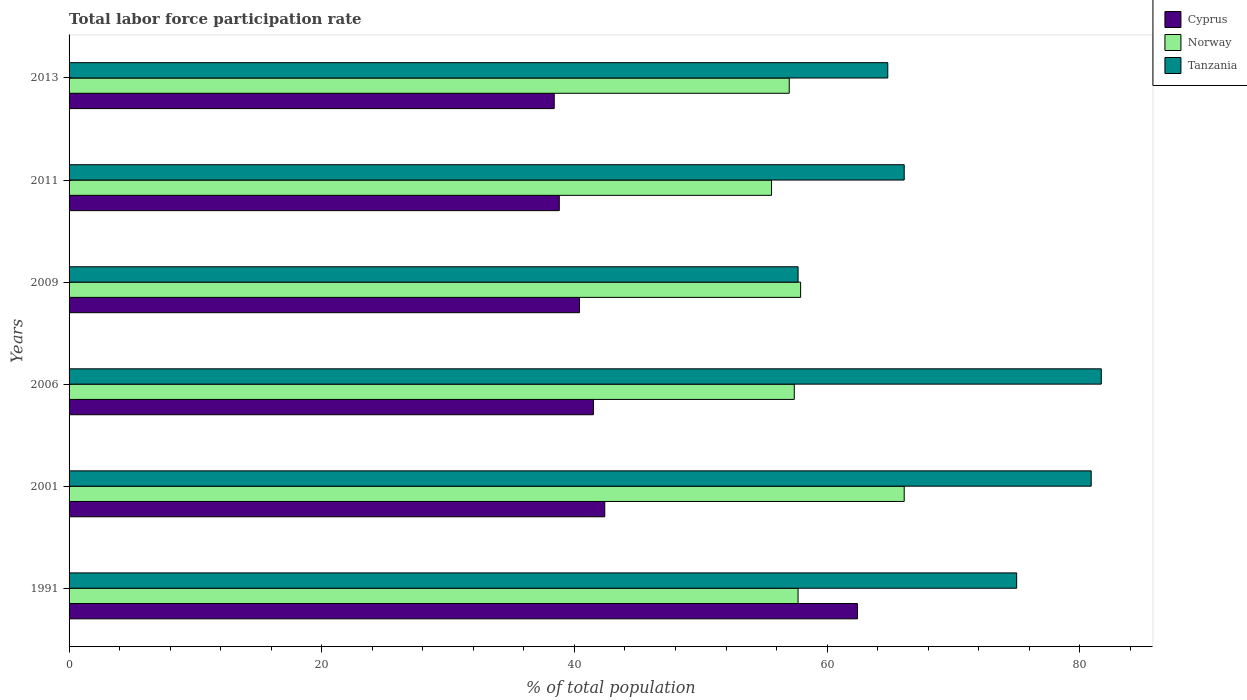How many different coloured bars are there?
Offer a terse response. 3. Are the number of bars per tick equal to the number of legend labels?
Your answer should be very brief. Yes. How many bars are there on the 4th tick from the top?
Give a very brief answer. 3. How many bars are there on the 6th tick from the bottom?
Your answer should be very brief. 3. What is the label of the 4th group of bars from the top?
Your answer should be compact. 2006. In how many cases, is the number of bars for a given year not equal to the number of legend labels?
Your answer should be very brief. 0. What is the total labor force participation rate in Norway in 2009?
Keep it short and to the point. 57.9. Across all years, what is the maximum total labor force participation rate in Norway?
Provide a succinct answer. 66.1. Across all years, what is the minimum total labor force participation rate in Cyprus?
Provide a short and direct response. 38.4. In which year was the total labor force participation rate in Norway minimum?
Your answer should be very brief. 2011. What is the total total labor force participation rate in Norway in the graph?
Offer a terse response. 351.7. What is the difference between the total labor force participation rate in Tanzania in 2001 and that in 2011?
Offer a terse response. 14.8. What is the difference between the total labor force participation rate in Cyprus in 2009 and the total labor force participation rate in Norway in 1991?
Give a very brief answer. -17.3. What is the average total labor force participation rate in Cyprus per year?
Give a very brief answer. 43.98. In the year 2006, what is the difference between the total labor force participation rate in Norway and total labor force participation rate in Tanzania?
Offer a very short reply. -24.3. In how many years, is the total labor force participation rate in Norway greater than 52 %?
Your answer should be compact. 6. What is the ratio of the total labor force participation rate in Norway in 2001 to that in 2013?
Make the answer very short. 1.16. What is the difference between the highest and the second highest total labor force participation rate in Norway?
Make the answer very short. 8.2. What is the difference between the highest and the lowest total labor force participation rate in Cyprus?
Provide a succinct answer. 24. In how many years, is the total labor force participation rate in Tanzania greater than the average total labor force participation rate in Tanzania taken over all years?
Your answer should be very brief. 3. Is the sum of the total labor force participation rate in Cyprus in 2011 and 2013 greater than the maximum total labor force participation rate in Tanzania across all years?
Offer a very short reply. No. What does the 1st bar from the top in 2011 represents?
Offer a very short reply. Tanzania. What does the 3rd bar from the bottom in 2013 represents?
Your response must be concise. Tanzania. How many bars are there?
Provide a succinct answer. 18. Are all the bars in the graph horizontal?
Provide a short and direct response. Yes. How many years are there in the graph?
Make the answer very short. 6. What is the difference between two consecutive major ticks on the X-axis?
Offer a very short reply. 20. How many legend labels are there?
Make the answer very short. 3. What is the title of the graph?
Keep it short and to the point. Total labor force participation rate. Does "Latin America(all income levels)" appear as one of the legend labels in the graph?
Your answer should be compact. No. What is the label or title of the X-axis?
Your response must be concise. % of total population. What is the label or title of the Y-axis?
Your response must be concise. Years. What is the % of total population of Cyprus in 1991?
Ensure brevity in your answer.  62.4. What is the % of total population of Norway in 1991?
Your answer should be very brief. 57.7. What is the % of total population of Tanzania in 1991?
Keep it short and to the point. 75. What is the % of total population of Cyprus in 2001?
Offer a terse response. 42.4. What is the % of total population in Norway in 2001?
Your answer should be compact. 66.1. What is the % of total population in Tanzania in 2001?
Offer a terse response. 80.9. What is the % of total population of Cyprus in 2006?
Keep it short and to the point. 41.5. What is the % of total population in Norway in 2006?
Provide a short and direct response. 57.4. What is the % of total population in Tanzania in 2006?
Your answer should be compact. 81.7. What is the % of total population of Cyprus in 2009?
Give a very brief answer. 40.4. What is the % of total population of Norway in 2009?
Your response must be concise. 57.9. What is the % of total population in Tanzania in 2009?
Your answer should be compact. 57.7. What is the % of total population of Cyprus in 2011?
Your answer should be compact. 38.8. What is the % of total population of Norway in 2011?
Keep it short and to the point. 55.6. What is the % of total population in Tanzania in 2011?
Your response must be concise. 66.1. What is the % of total population of Cyprus in 2013?
Offer a very short reply. 38.4. What is the % of total population of Tanzania in 2013?
Your response must be concise. 64.8. Across all years, what is the maximum % of total population in Cyprus?
Offer a terse response. 62.4. Across all years, what is the maximum % of total population in Norway?
Give a very brief answer. 66.1. Across all years, what is the maximum % of total population in Tanzania?
Offer a very short reply. 81.7. Across all years, what is the minimum % of total population in Cyprus?
Make the answer very short. 38.4. Across all years, what is the minimum % of total population in Norway?
Your answer should be very brief. 55.6. Across all years, what is the minimum % of total population of Tanzania?
Provide a succinct answer. 57.7. What is the total % of total population in Cyprus in the graph?
Make the answer very short. 263.9. What is the total % of total population in Norway in the graph?
Offer a terse response. 351.7. What is the total % of total population in Tanzania in the graph?
Your answer should be compact. 426.2. What is the difference between the % of total population in Cyprus in 1991 and that in 2001?
Your response must be concise. 20. What is the difference between the % of total population in Cyprus in 1991 and that in 2006?
Make the answer very short. 20.9. What is the difference between the % of total population of Cyprus in 1991 and that in 2009?
Provide a short and direct response. 22. What is the difference between the % of total population in Tanzania in 1991 and that in 2009?
Your response must be concise. 17.3. What is the difference between the % of total population in Cyprus in 1991 and that in 2011?
Offer a terse response. 23.6. What is the difference between the % of total population of Cyprus in 1991 and that in 2013?
Keep it short and to the point. 24. What is the difference between the % of total population of Cyprus in 2001 and that in 2006?
Give a very brief answer. 0.9. What is the difference between the % of total population in Norway in 2001 and that in 2006?
Your response must be concise. 8.7. What is the difference between the % of total population of Tanzania in 2001 and that in 2006?
Your answer should be very brief. -0.8. What is the difference between the % of total population of Cyprus in 2001 and that in 2009?
Your answer should be very brief. 2. What is the difference between the % of total population of Norway in 2001 and that in 2009?
Ensure brevity in your answer.  8.2. What is the difference between the % of total population of Tanzania in 2001 and that in 2009?
Offer a very short reply. 23.2. What is the difference between the % of total population of Cyprus in 2001 and that in 2011?
Make the answer very short. 3.6. What is the difference between the % of total population of Norway in 2001 and that in 2011?
Give a very brief answer. 10.5. What is the difference between the % of total population in Norway in 2001 and that in 2013?
Your response must be concise. 9.1. What is the difference between the % of total population in Cyprus in 2006 and that in 2009?
Offer a terse response. 1.1. What is the difference between the % of total population of Tanzania in 2006 and that in 2011?
Your answer should be very brief. 15.6. What is the difference between the % of total population in Norway in 2006 and that in 2013?
Give a very brief answer. 0.4. What is the difference between the % of total population in Norway in 2009 and that in 2011?
Offer a terse response. 2.3. What is the difference between the % of total population in Norway in 2009 and that in 2013?
Your answer should be compact. 0.9. What is the difference between the % of total population of Norway in 2011 and that in 2013?
Your response must be concise. -1.4. What is the difference between the % of total population in Tanzania in 2011 and that in 2013?
Give a very brief answer. 1.3. What is the difference between the % of total population of Cyprus in 1991 and the % of total population of Norway in 2001?
Your answer should be very brief. -3.7. What is the difference between the % of total population in Cyprus in 1991 and the % of total population in Tanzania in 2001?
Make the answer very short. -18.5. What is the difference between the % of total population in Norway in 1991 and the % of total population in Tanzania in 2001?
Ensure brevity in your answer.  -23.2. What is the difference between the % of total population of Cyprus in 1991 and the % of total population of Tanzania in 2006?
Your response must be concise. -19.3. What is the difference between the % of total population of Norway in 1991 and the % of total population of Tanzania in 2006?
Your answer should be very brief. -24. What is the difference between the % of total population of Cyprus in 1991 and the % of total population of Tanzania in 2009?
Keep it short and to the point. 4.7. What is the difference between the % of total population in Norway in 1991 and the % of total population in Tanzania in 2009?
Make the answer very short. 0. What is the difference between the % of total population in Cyprus in 1991 and the % of total population in Tanzania in 2011?
Provide a short and direct response. -3.7. What is the difference between the % of total population of Norway in 1991 and the % of total population of Tanzania in 2011?
Make the answer very short. -8.4. What is the difference between the % of total population in Cyprus in 1991 and the % of total population in Tanzania in 2013?
Your answer should be very brief. -2.4. What is the difference between the % of total population of Norway in 1991 and the % of total population of Tanzania in 2013?
Ensure brevity in your answer.  -7.1. What is the difference between the % of total population of Cyprus in 2001 and the % of total population of Tanzania in 2006?
Provide a short and direct response. -39.3. What is the difference between the % of total population of Norway in 2001 and the % of total population of Tanzania in 2006?
Your response must be concise. -15.6. What is the difference between the % of total population of Cyprus in 2001 and the % of total population of Norway in 2009?
Provide a short and direct response. -15.5. What is the difference between the % of total population of Cyprus in 2001 and the % of total population of Tanzania in 2009?
Your response must be concise. -15.3. What is the difference between the % of total population in Cyprus in 2001 and the % of total population in Norway in 2011?
Your answer should be very brief. -13.2. What is the difference between the % of total population of Cyprus in 2001 and the % of total population of Tanzania in 2011?
Your answer should be very brief. -23.7. What is the difference between the % of total population of Norway in 2001 and the % of total population of Tanzania in 2011?
Provide a short and direct response. 0. What is the difference between the % of total population of Cyprus in 2001 and the % of total population of Norway in 2013?
Provide a succinct answer. -14.6. What is the difference between the % of total population in Cyprus in 2001 and the % of total population in Tanzania in 2013?
Your response must be concise. -22.4. What is the difference between the % of total population in Norway in 2001 and the % of total population in Tanzania in 2013?
Offer a terse response. 1.3. What is the difference between the % of total population of Cyprus in 2006 and the % of total population of Norway in 2009?
Your answer should be compact. -16.4. What is the difference between the % of total population of Cyprus in 2006 and the % of total population of Tanzania in 2009?
Your answer should be very brief. -16.2. What is the difference between the % of total population in Cyprus in 2006 and the % of total population in Norway in 2011?
Offer a terse response. -14.1. What is the difference between the % of total population in Cyprus in 2006 and the % of total population in Tanzania in 2011?
Your answer should be compact. -24.6. What is the difference between the % of total population of Norway in 2006 and the % of total population of Tanzania in 2011?
Your answer should be very brief. -8.7. What is the difference between the % of total population in Cyprus in 2006 and the % of total population in Norway in 2013?
Keep it short and to the point. -15.5. What is the difference between the % of total population in Cyprus in 2006 and the % of total population in Tanzania in 2013?
Ensure brevity in your answer.  -23.3. What is the difference between the % of total population of Cyprus in 2009 and the % of total population of Norway in 2011?
Keep it short and to the point. -15.2. What is the difference between the % of total population of Cyprus in 2009 and the % of total population of Tanzania in 2011?
Ensure brevity in your answer.  -25.7. What is the difference between the % of total population of Cyprus in 2009 and the % of total population of Norway in 2013?
Your answer should be compact. -16.6. What is the difference between the % of total population of Cyprus in 2009 and the % of total population of Tanzania in 2013?
Provide a succinct answer. -24.4. What is the difference between the % of total population of Norway in 2009 and the % of total population of Tanzania in 2013?
Keep it short and to the point. -6.9. What is the difference between the % of total population in Cyprus in 2011 and the % of total population in Norway in 2013?
Keep it short and to the point. -18.2. What is the difference between the % of total population in Norway in 2011 and the % of total population in Tanzania in 2013?
Your answer should be very brief. -9.2. What is the average % of total population of Cyprus per year?
Ensure brevity in your answer.  43.98. What is the average % of total population of Norway per year?
Provide a succinct answer. 58.62. What is the average % of total population of Tanzania per year?
Give a very brief answer. 71.03. In the year 1991, what is the difference between the % of total population in Cyprus and % of total population in Norway?
Provide a succinct answer. 4.7. In the year 1991, what is the difference between the % of total population in Cyprus and % of total population in Tanzania?
Give a very brief answer. -12.6. In the year 1991, what is the difference between the % of total population in Norway and % of total population in Tanzania?
Offer a very short reply. -17.3. In the year 2001, what is the difference between the % of total population of Cyprus and % of total population of Norway?
Give a very brief answer. -23.7. In the year 2001, what is the difference between the % of total population of Cyprus and % of total population of Tanzania?
Offer a terse response. -38.5. In the year 2001, what is the difference between the % of total population in Norway and % of total population in Tanzania?
Offer a very short reply. -14.8. In the year 2006, what is the difference between the % of total population of Cyprus and % of total population of Norway?
Your response must be concise. -15.9. In the year 2006, what is the difference between the % of total population of Cyprus and % of total population of Tanzania?
Ensure brevity in your answer.  -40.2. In the year 2006, what is the difference between the % of total population in Norway and % of total population in Tanzania?
Provide a short and direct response. -24.3. In the year 2009, what is the difference between the % of total population in Cyprus and % of total population in Norway?
Offer a very short reply. -17.5. In the year 2009, what is the difference between the % of total population of Cyprus and % of total population of Tanzania?
Ensure brevity in your answer.  -17.3. In the year 2009, what is the difference between the % of total population of Norway and % of total population of Tanzania?
Give a very brief answer. 0.2. In the year 2011, what is the difference between the % of total population of Cyprus and % of total population of Norway?
Your answer should be very brief. -16.8. In the year 2011, what is the difference between the % of total population of Cyprus and % of total population of Tanzania?
Keep it short and to the point. -27.3. In the year 2011, what is the difference between the % of total population in Norway and % of total population in Tanzania?
Your answer should be compact. -10.5. In the year 2013, what is the difference between the % of total population of Cyprus and % of total population of Norway?
Provide a succinct answer. -18.6. In the year 2013, what is the difference between the % of total population of Cyprus and % of total population of Tanzania?
Your answer should be compact. -26.4. In the year 2013, what is the difference between the % of total population in Norway and % of total population in Tanzania?
Keep it short and to the point. -7.8. What is the ratio of the % of total population in Cyprus in 1991 to that in 2001?
Provide a succinct answer. 1.47. What is the ratio of the % of total population of Norway in 1991 to that in 2001?
Keep it short and to the point. 0.87. What is the ratio of the % of total population in Tanzania in 1991 to that in 2001?
Offer a terse response. 0.93. What is the ratio of the % of total population in Cyprus in 1991 to that in 2006?
Offer a terse response. 1.5. What is the ratio of the % of total population of Norway in 1991 to that in 2006?
Your response must be concise. 1.01. What is the ratio of the % of total population in Tanzania in 1991 to that in 2006?
Ensure brevity in your answer.  0.92. What is the ratio of the % of total population in Cyprus in 1991 to that in 2009?
Give a very brief answer. 1.54. What is the ratio of the % of total population in Tanzania in 1991 to that in 2009?
Ensure brevity in your answer.  1.3. What is the ratio of the % of total population in Cyprus in 1991 to that in 2011?
Ensure brevity in your answer.  1.61. What is the ratio of the % of total population of Norway in 1991 to that in 2011?
Provide a short and direct response. 1.04. What is the ratio of the % of total population in Tanzania in 1991 to that in 2011?
Your answer should be very brief. 1.13. What is the ratio of the % of total population of Cyprus in 1991 to that in 2013?
Make the answer very short. 1.62. What is the ratio of the % of total population of Norway in 1991 to that in 2013?
Offer a very short reply. 1.01. What is the ratio of the % of total population in Tanzania in 1991 to that in 2013?
Your answer should be compact. 1.16. What is the ratio of the % of total population of Cyprus in 2001 to that in 2006?
Ensure brevity in your answer.  1.02. What is the ratio of the % of total population in Norway in 2001 to that in 2006?
Offer a terse response. 1.15. What is the ratio of the % of total population of Tanzania in 2001 to that in 2006?
Provide a short and direct response. 0.99. What is the ratio of the % of total population in Cyprus in 2001 to that in 2009?
Provide a short and direct response. 1.05. What is the ratio of the % of total population of Norway in 2001 to that in 2009?
Your answer should be compact. 1.14. What is the ratio of the % of total population of Tanzania in 2001 to that in 2009?
Provide a short and direct response. 1.4. What is the ratio of the % of total population in Cyprus in 2001 to that in 2011?
Provide a short and direct response. 1.09. What is the ratio of the % of total population in Norway in 2001 to that in 2011?
Your answer should be very brief. 1.19. What is the ratio of the % of total population of Tanzania in 2001 to that in 2011?
Provide a succinct answer. 1.22. What is the ratio of the % of total population of Cyprus in 2001 to that in 2013?
Make the answer very short. 1.1. What is the ratio of the % of total population in Norway in 2001 to that in 2013?
Your answer should be very brief. 1.16. What is the ratio of the % of total population of Tanzania in 2001 to that in 2013?
Your answer should be very brief. 1.25. What is the ratio of the % of total population of Cyprus in 2006 to that in 2009?
Offer a terse response. 1.03. What is the ratio of the % of total population in Tanzania in 2006 to that in 2009?
Your answer should be very brief. 1.42. What is the ratio of the % of total population of Cyprus in 2006 to that in 2011?
Offer a very short reply. 1.07. What is the ratio of the % of total population of Norway in 2006 to that in 2011?
Provide a succinct answer. 1.03. What is the ratio of the % of total population in Tanzania in 2006 to that in 2011?
Give a very brief answer. 1.24. What is the ratio of the % of total population of Cyprus in 2006 to that in 2013?
Offer a terse response. 1.08. What is the ratio of the % of total population of Tanzania in 2006 to that in 2013?
Your answer should be very brief. 1.26. What is the ratio of the % of total population in Cyprus in 2009 to that in 2011?
Ensure brevity in your answer.  1.04. What is the ratio of the % of total population of Norway in 2009 to that in 2011?
Offer a very short reply. 1.04. What is the ratio of the % of total population in Tanzania in 2009 to that in 2011?
Keep it short and to the point. 0.87. What is the ratio of the % of total population of Cyprus in 2009 to that in 2013?
Give a very brief answer. 1.05. What is the ratio of the % of total population in Norway in 2009 to that in 2013?
Offer a terse response. 1.02. What is the ratio of the % of total population in Tanzania in 2009 to that in 2013?
Keep it short and to the point. 0.89. What is the ratio of the % of total population of Cyprus in 2011 to that in 2013?
Provide a short and direct response. 1.01. What is the ratio of the % of total population of Norway in 2011 to that in 2013?
Keep it short and to the point. 0.98. What is the ratio of the % of total population of Tanzania in 2011 to that in 2013?
Make the answer very short. 1.02. What is the difference between the highest and the lowest % of total population of Norway?
Your answer should be very brief. 10.5. What is the difference between the highest and the lowest % of total population of Tanzania?
Your answer should be very brief. 24. 